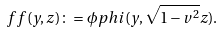Convert formula to latex. <formula><loc_0><loc_0><loc_500><loc_500>\ f f ( y , z ) \colon = \phi p h i ( y , \sqrt { 1 - v ^ { 2 } } z ) .</formula> 